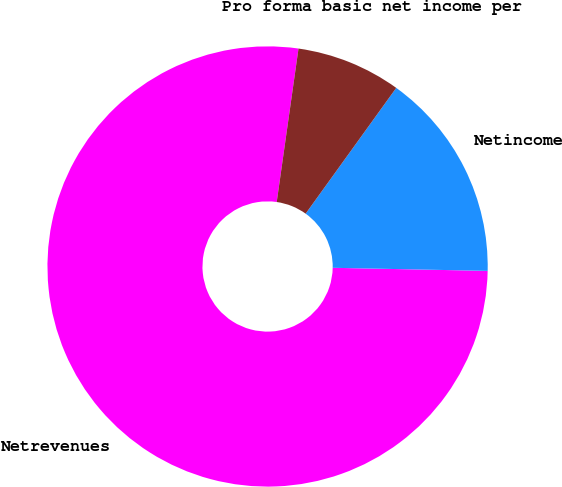Convert chart. <chart><loc_0><loc_0><loc_500><loc_500><pie_chart><fcel>Netrevenues<fcel>Netincome<fcel>Pro forma basic net income per<fcel>Unnamed: 3<nl><fcel>76.92%<fcel>15.38%<fcel>7.69%<fcel>0.0%<nl></chart> 